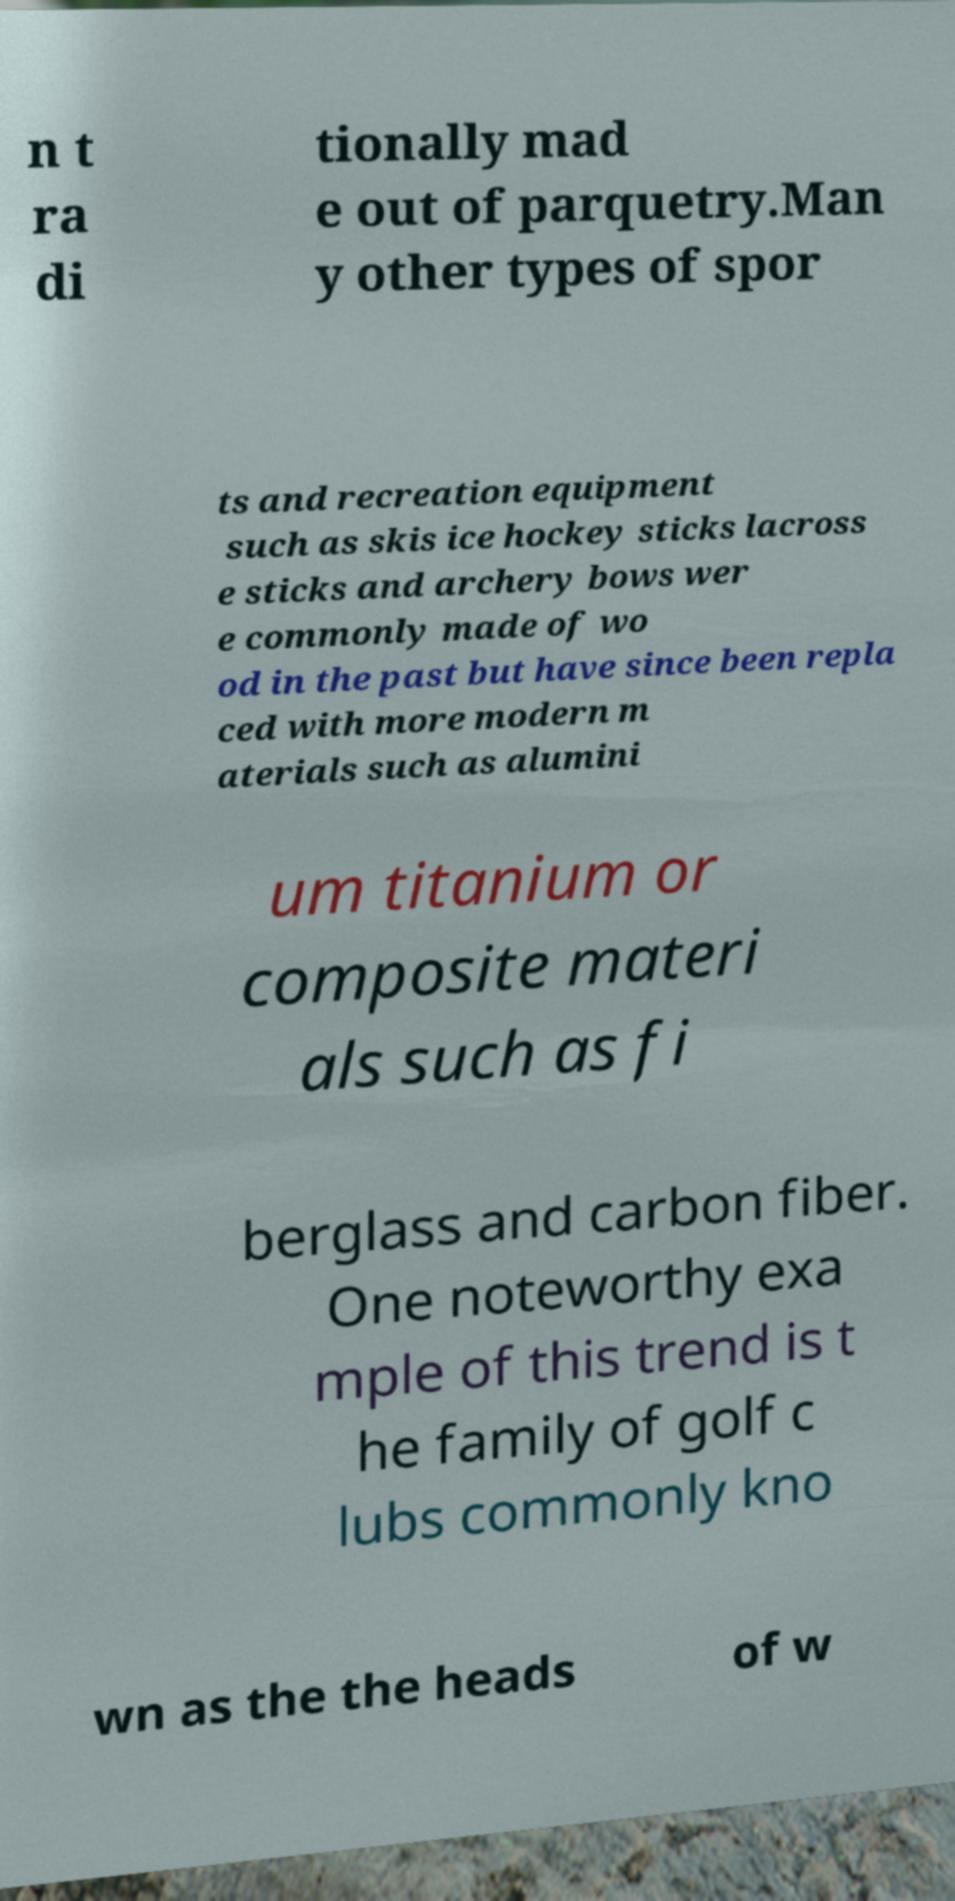Please read and relay the text visible in this image. What does it say? n t ra di tionally mad e out of parquetry.Man y other types of spor ts and recreation equipment such as skis ice hockey sticks lacross e sticks and archery bows wer e commonly made of wo od in the past but have since been repla ced with more modern m aterials such as alumini um titanium or composite materi als such as fi berglass and carbon fiber. One noteworthy exa mple of this trend is t he family of golf c lubs commonly kno wn as the the heads of w 